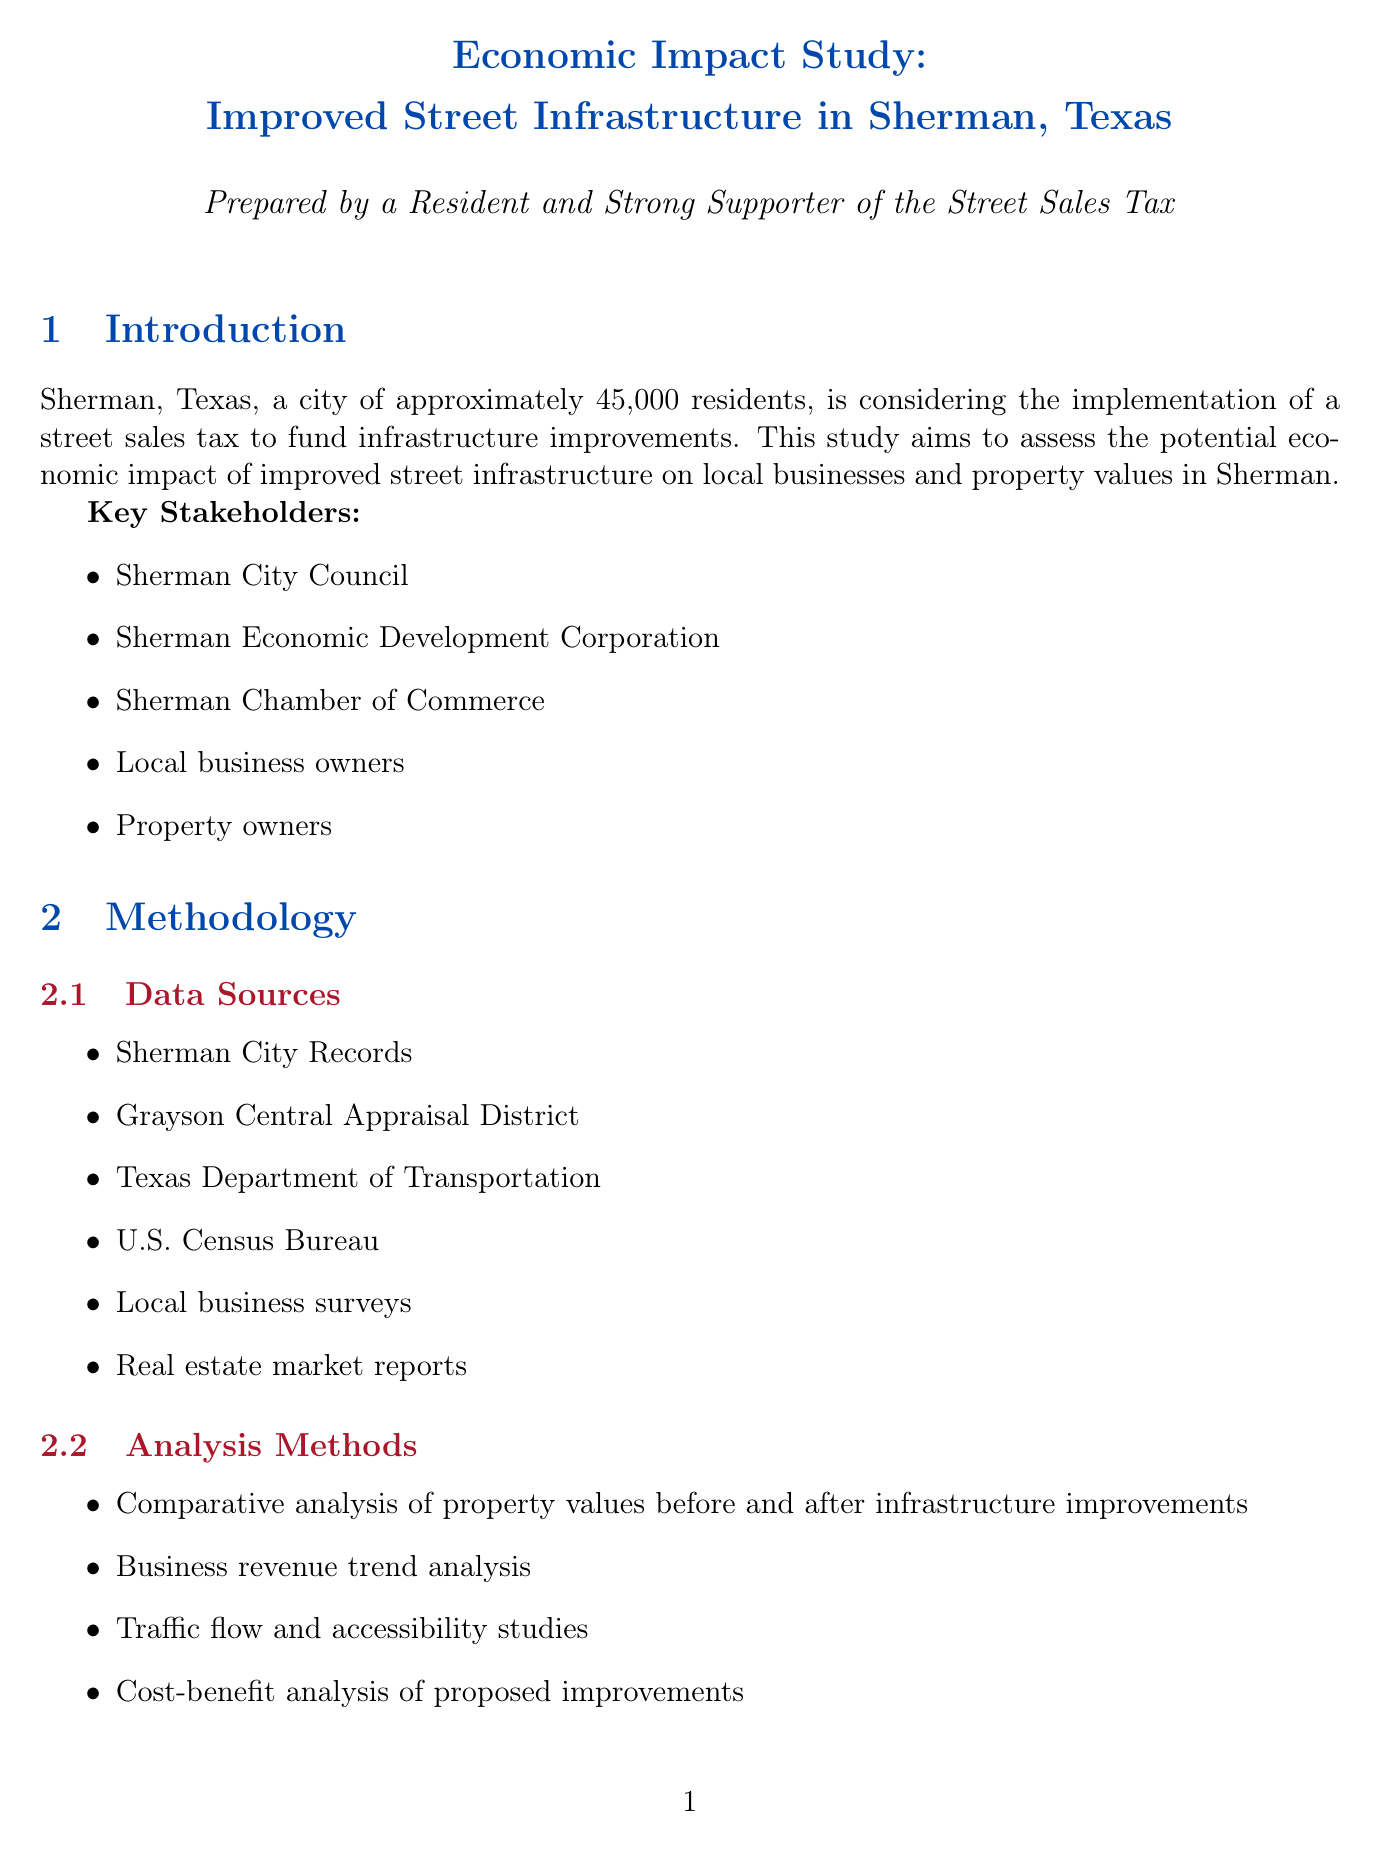What is the proposed increase in local sales tax? The proposed increase in local sales tax is dedicated to street improvements and is 0.25%.
Answer: 0.25% What is the estimated annual revenue from the proposed tax? The estimated annual revenue from the proposed tax is mentioned in the funding mechanism section and is $3.5 million.
Answer: $3.5 million How much did retail sales increase in Downtown Sherman after improvements? In Downtown Sherman, retail sales increased by 15% after streetscape improvements on Travis Street.
Answer: 15% How many new jobs are estimated to be created in the Sherman Town Center project? The Sherman Town Center project is estimated to create 150 new jobs in retail and service sectors.
Answer: 150 What is the expected increase in residential property values near improved streets? The expected increase in residential property values near improved streets is estimated to be 8-15%.
Answer: 8-15% What is one of the potential challenges mentioned in the document? One potential challenge mentioned is short-term disruption to businesses during construction.
Answer: Short-term disruption What key stakeholder is involved in this study? The Sherman Chamber of Commerce is one of the key stakeholders involved in this study.
Answer: Sherman Chamber of Commerce What improvement project is located on U.S. Highway 75? The improvement project on U.S. Highway 75 involves road widening and traffic signal optimization.
Answer: Road widening and traffic signal optimization 